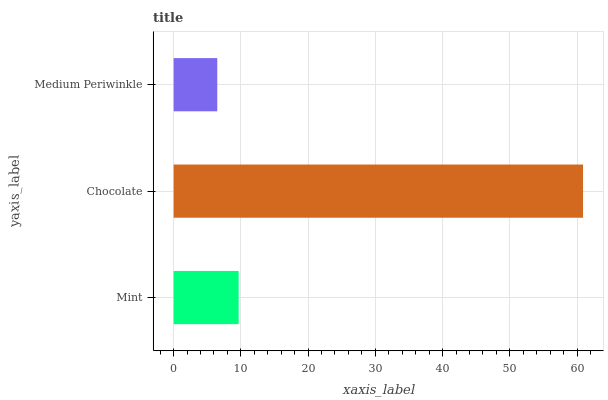Is Medium Periwinkle the minimum?
Answer yes or no. Yes. Is Chocolate the maximum?
Answer yes or no. Yes. Is Chocolate the minimum?
Answer yes or no. No. Is Medium Periwinkle the maximum?
Answer yes or no. No. Is Chocolate greater than Medium Periwinkle?
Answer yes or no. Yes. Is Medium Periwinkle less than Chocolate?
Answer yes or no. Yes. Is Medium Periwinkle greater than Chocolate?
Answer yes or no. No. Is Chocolate less than Medium Periwinkle?
Answer yes or no. No. Is Mint the high median?
Answer yes or no. Yes. Is Mint the low median?
Answer yes or no. Yes. Is Medium Periwinkle the high median?
Answer yes or no. No. Is Chocolate the low median?
Answer yes or no. No. 